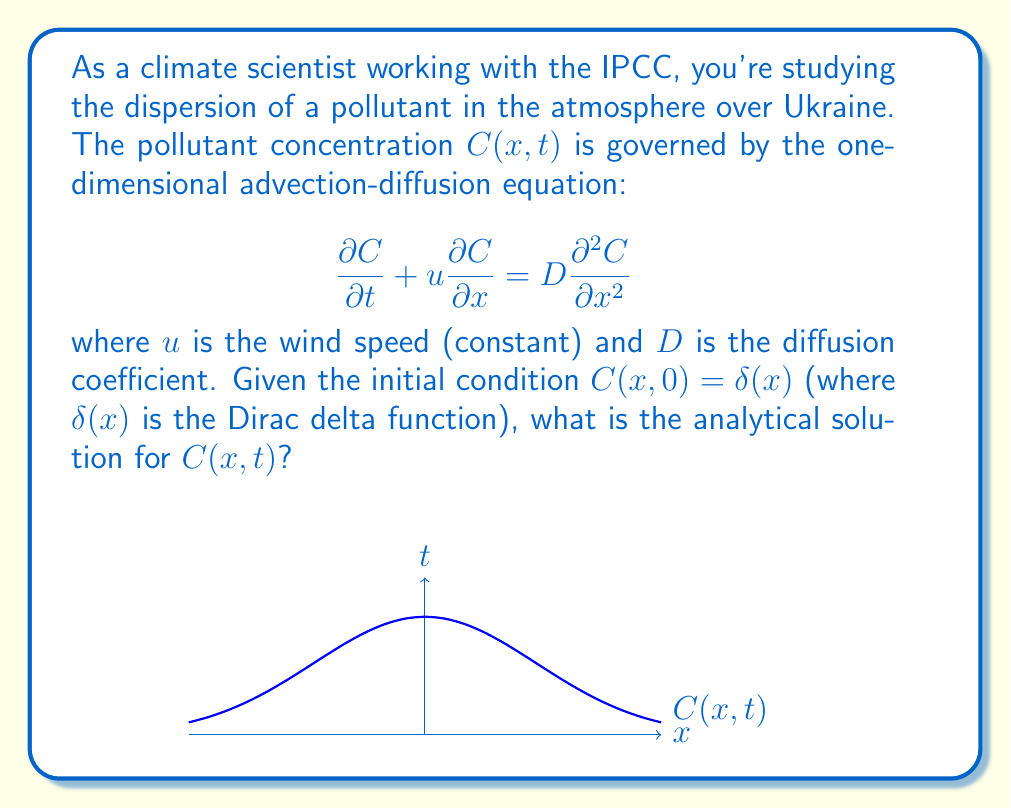What is the answer to this math problem? To solve this problem, we'll follow these steps:

1) The general solution for the advection-diffusion equation with a point source initial condition is:

   $$C(x,t) = \frac{M}{\sqrt{4\pi Dt}} \exp\left(-\frac{(x-ut)^2}{4Dt}\right)$$

   where $M$ is the total mass of the pollutant.

2) In our case, the initial condition is a Dirac delta function, which represents an instantaneous point source release. The Dirac delta function has the property:

   $$\int_{-\infty}^{\infty} \delta(x) dx = 1$$

3) This means that the total mass $M$ in our case is 1.

4) Substituting $M=1$ into the general solution:

   $$C(x,t) = \frac{1}{\sqrt{4\pi Dt}} \exp\left(-\frac{(x-ut)^2}{4Dt}\right)$$

5) This is the analytical solution for the concentration $C(x,t)$ at any position $x$ and time $t$.

6) The solution represents a Gaussian distribution that spreads out over time, with its peak moving at speed $u$.

7) The width of the distribution increases with time as $\sqrt{4Dt}$, reflecting the diffusive spread of the pollutant.
Answer: $$C(x,t) = \frac{1}{\sqrt{4\pi Dt}} \exp\left(-\frac{(x-ut)^2}{4Dt}\right)$$ 